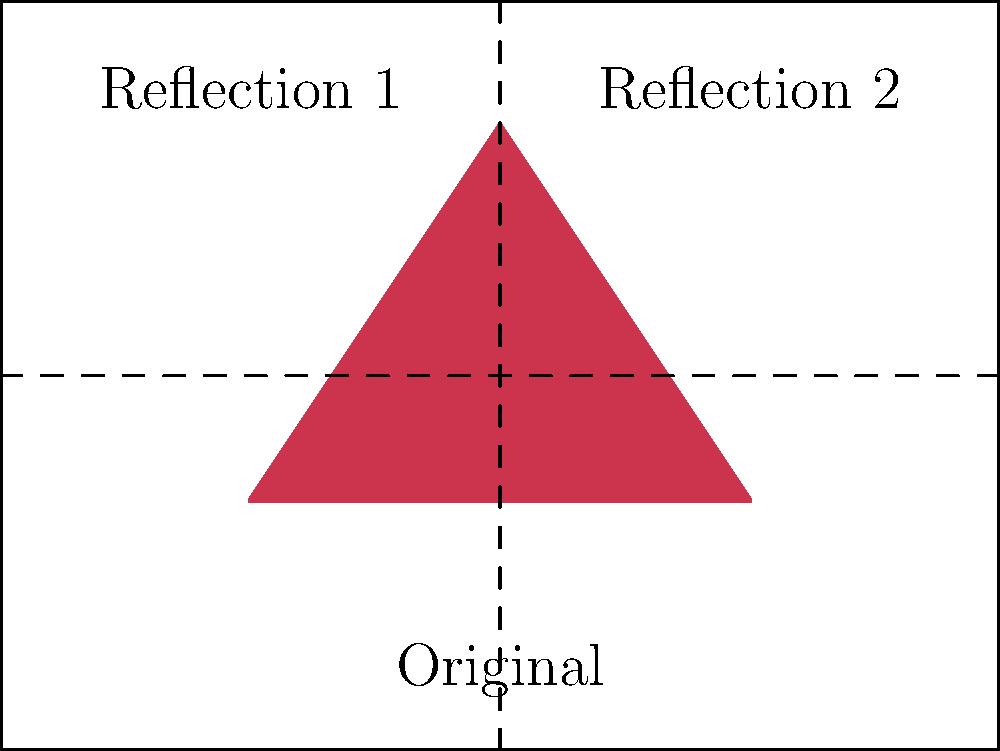In your abstract painting process, you've created a triangular shape and want to reflect it to create a symmetrical pattern. If you reflect the original shape across both the x-axis and y-axis, how many total shapes (including the original) will be in the final symmetrical composition? Let's approach this step-by-step:

1. We start with the original triangular shape in the fourth quadrant of the coordinate plane.

2. Reflecting across the x-axis:
   - This creates a mirror image of the original shape in the first quadrant.
   - After this step, we have 2 shapes.

3. Reflecting across the y-axis:
   - This creates mirror images of both existing shapes.
   - The original shape in the fourth quadrant is reflected into the third quadrant.
   - The shape in the first quadrant (from step 2) is reflected into the second quadrant.

4. Counting the final number of shapes:
   - Original shape in the fourth quadrant
   - Reflection across x-axis in the first quadrant
   - Reflection across y-axis of the original shape in the third quadrant
   - Reflection across both x and y axes in the second quadrant

Therefore, the final symmetrical composition will contain 4 shapes in total.

This process creates a radially symmetric pattern around the origin, which is a common technique in abstract art to create balance and harmony in a composition.
Answer: 4 shapes 